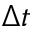<formula> <loc_0><loc_0><loc_500><loc_500>\Delta t</formula> 